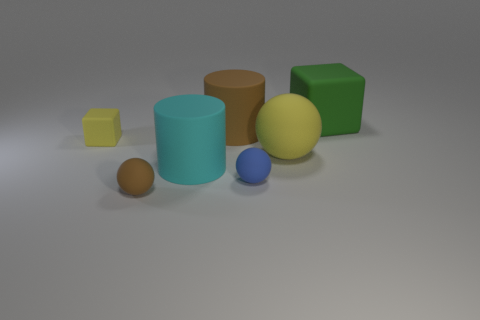Subtract all large rubber balls. How many balls are left? 2 Subtract 1 balls. How many balls are left? 2 Add 3 large red metallic cylinders. How many objects exist? 10 Subtract all gray balls. Subtract all yellow cubes. How many balls are left? 3 Subtract all cylinders. How many objects are left? 5 Subtract 0 blue cylinders. How many objects are left? 7 Subtract all yellow rubber spheres. Subtract all brown rubber cylinders. How many objects are left? 5 Add 4 small brown matte spheres. How many small brown matte spheres are left? 5 Add 6 tiny gray rubber cubes. How many tiny gray rubber cubes exist? 6 